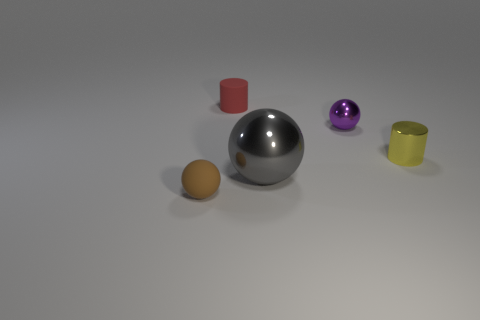The tiny ball that is to the right of the tiny thing left of the small matte cylinder is made of what material?
Offer a very short reply. Metal. Is the small red thing the same shape as the big thing?
Provide a succinct answer. No. What number of cylinders are both in front of the small matte cylinder and on the left side of the tiny yellow object?
Keep it short and to the point. 0. Are there an equal number of small brown rubber objects in front of the gray shiny sphere and gray balls to the left of the rubber cylinder?
Your response must be concise. No. Is the size of the brown thing that is to the left of the gray ball the same as the object that is behind the purple thing?
Make the answer very short. Yes. What material is the tiny object that is on the left side of the large gray metal ball and in front of the small red cylinder?
Keep it short and to the point. Rubber. Is the number of small brown metallic objects less than the number of rubber balls?
Your answer should be very brief. Yes. There is a shiny thing that is behind the small cylinder that is right of the gray thing; how big is it?
Your answer should be very brief. Small. What is the shape of the small metal thing that is in front of the tiny ball that is on the right side of the tiny object in front of the yellow metallic thing?
Provide a short and direct response. Cylinder. What color is the big ball that is the same material as the yellow object?
Your answer should be very brief. Gray. 